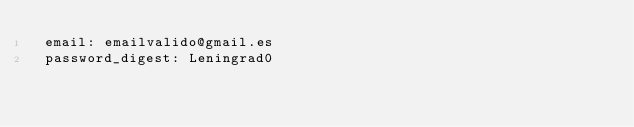Convert code to text. <code><loc_0><loc_0><loc_500><loc_500><_YAML_> email: emailvalido@gmail.es
 password_digest: Leningrad0
</code> 